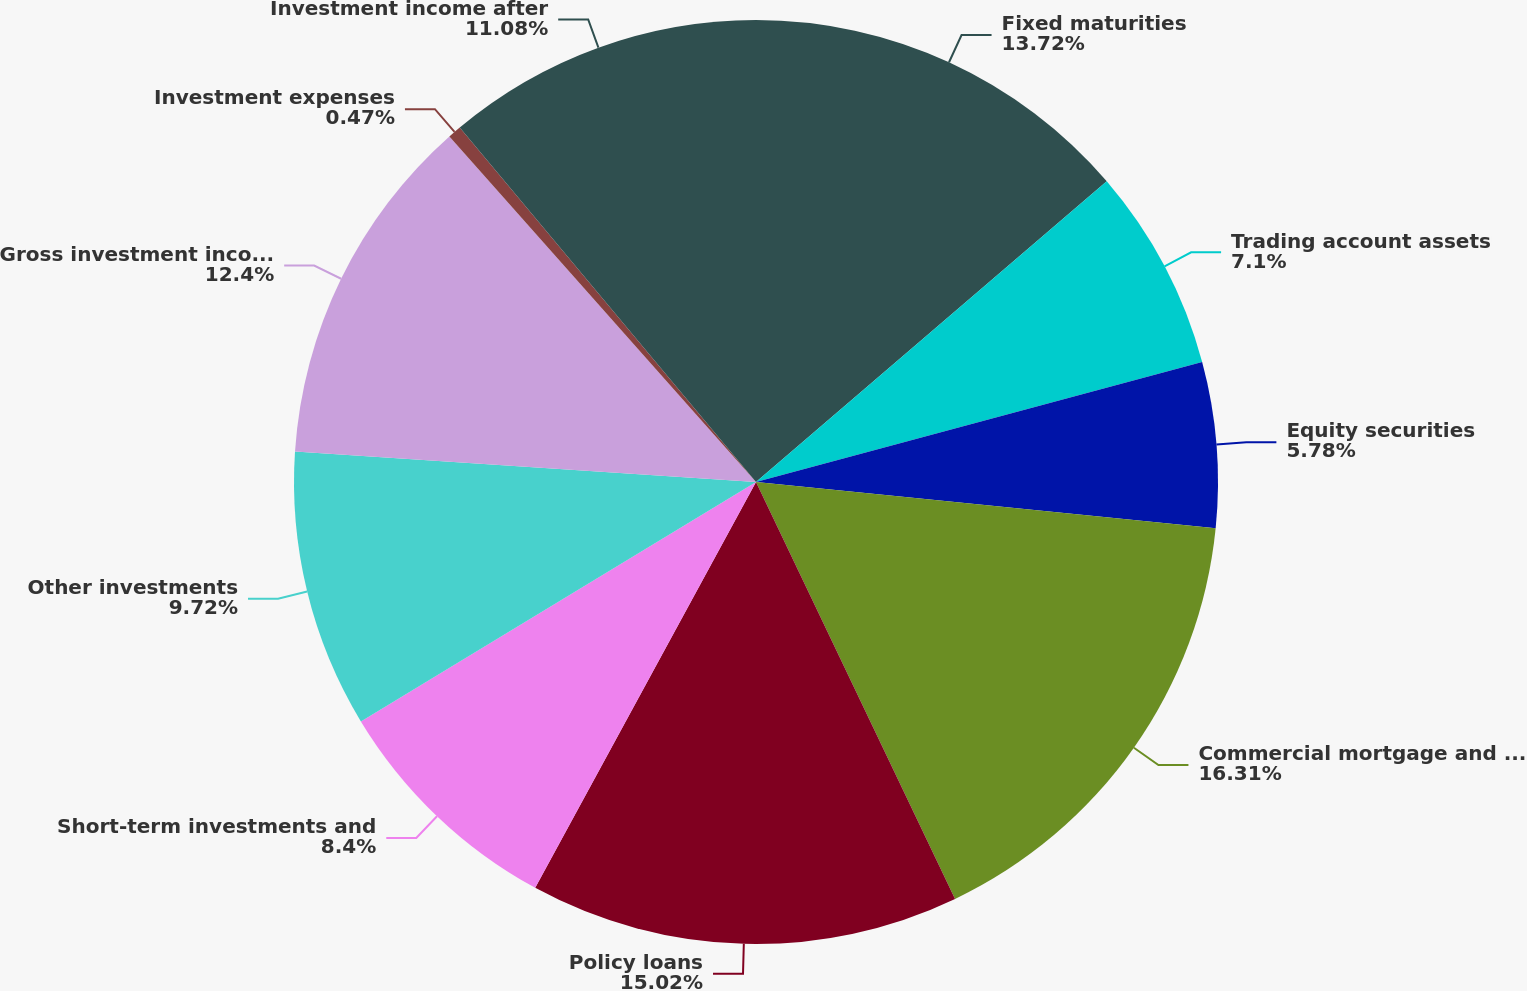<chart> <loc_0><loc_0><loc_500><loc_500><pie_chart><fcel>Fixed maturities<fcel>Trading account assets<fcel>Equity securities<fcel>Commercial mortgage and other<fcel>Policy loans<fcel>Short-term investments and<fcel>Other investments<fcel>Gross investment income before<fcel>Investment expenses<fcel>Investment income after<nl><fcel>13.72%<fcel>7.1%<fcel>5.78%<fcel>16.31%<fcel>15.02%<fcel>8.4%<fcel>9.72%<fcel>12.4%<fcel>0.47%<fcel>11.08%<nl></chart> 